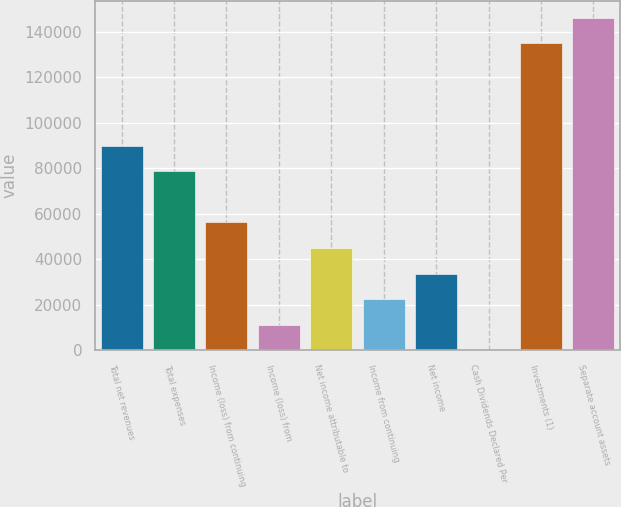<chart> <loc_0><loc_0><loc_500><loc_500><bar_chart><fcel>Total net revenues<fcel>Total expenses<fcel>Income (loss) from continuing<fcel>Income (loss) from<fcel>Net income attributable to<fcel>Income from continuing<fcel>Net income<fcel>Cash Dividends Declared Per<fcel>Investments (1)<fcel>Separate account assets<nl><fcel>90022.5<fcel>78769.8<fcel>56264.3<fcel>11253.4<fcel>45011.6<fcel>22506.1<fcel>33758.9<fcel>0.68<fcel>135033<fcel>146286<nl></chart> 